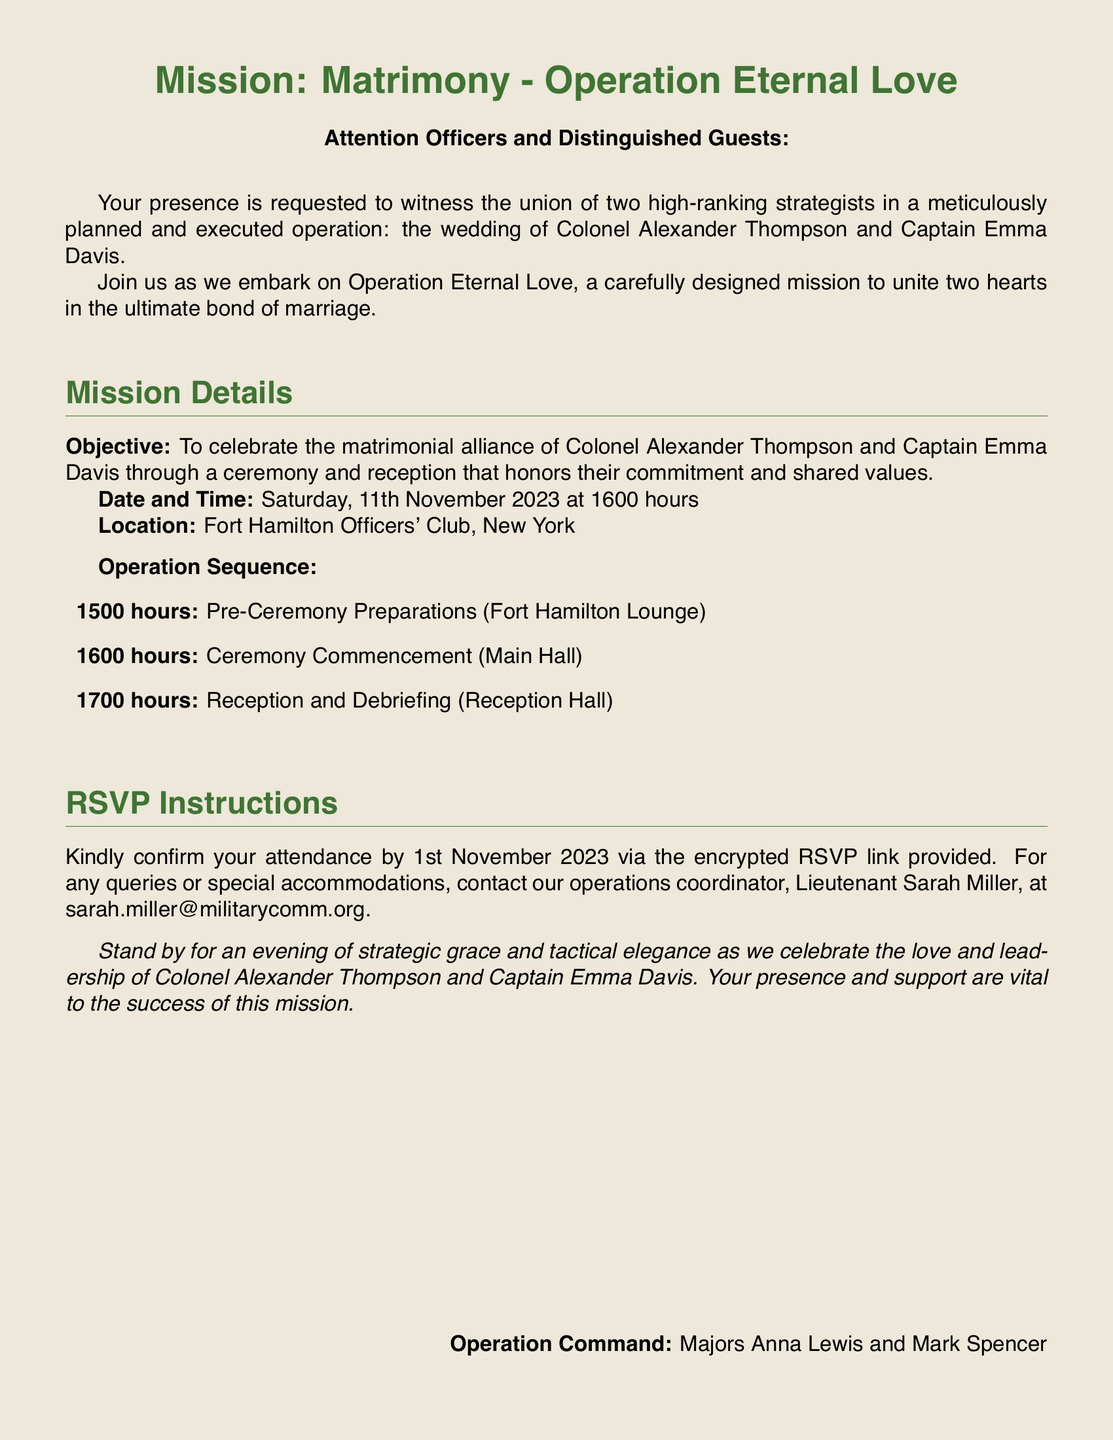What is the mission name? The document states the mission name as "Mission: Matrimony - Operation Eternal Love."
Answer: Mission: Matrimony - Operation Eternal Love Who are the couple getting married? The document lists the names of the couple as Colonel Alexander Thompson and Captain Emma Davis.
Answer: Colonel Alexander Thompson and Captain Emma Davis What is the date of the wedding ceremony? The document specifies the date of the ceremony as "Saturday, 11th November 2023."
Answer: Saturday, 11th November 2023 What time does the reception begin? The document indicates that the reception begins at "1700 hours."
Answer: 1700 hours Who should be contacted for special accommodations? The document mentions Lieutenant Sarah Miller as the contact person for special accommodations.
Answer: Lieutenant Sarah Miller What is the location of the wedding? The document states that the wedding will take place at "Fort Hamilton Officers' Club, New York."
Answer: Fort Hamilton Officers' Club, New York What time is the ceremony scheduled to start? The document specifies that the ceremony will commence at "1600 hours."
Answer: 1600 hours What is the last date to RSVP? The document indicates that the last date to RSVP is "1st November 2023."
Answer: 1st November 2023 Who are the operation commanders? The document lists Majors Anna Lewis and Mark Spencer as the operation commanders.
Answer: Majors Anna Lewis and Mark Spencer 